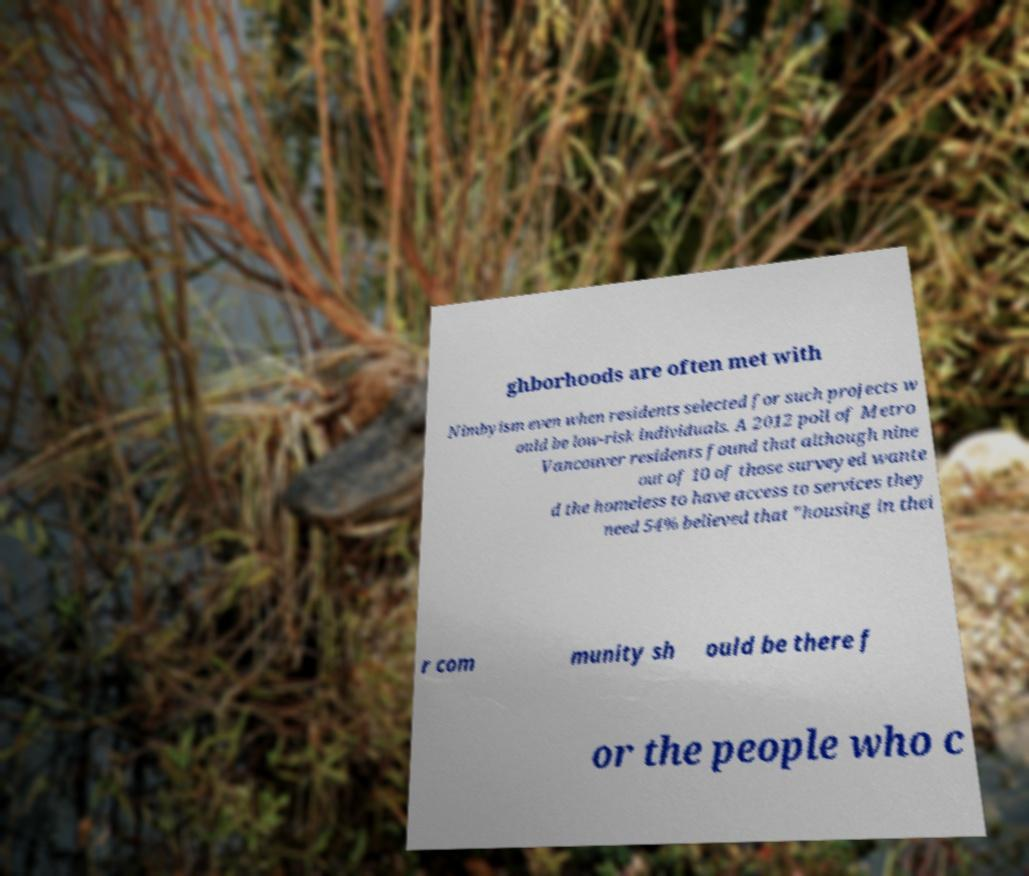I need the written content from this picture converted into text. Can you do that? ghborhoods are often met with Nimbyism even when residents selected for such projects w ould be low-risk individuals. A 2012 poll of Metro Vancouver residents found that although nine out of 10 of those surveyed wante d the homeless to have access to services they need 54% believed that "housing in thei r com munity sh ould be there f or the people who c 